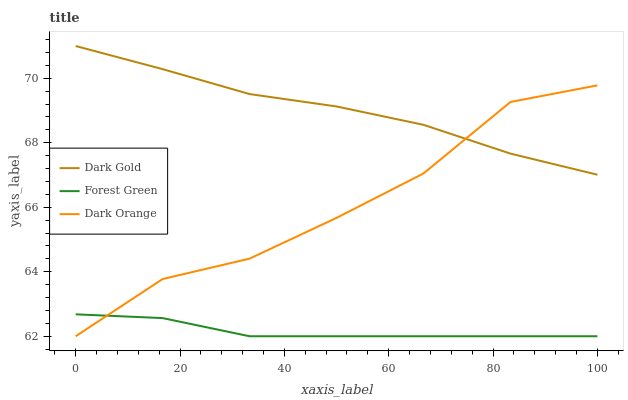Does Forest Green have the minimum area under the curve?
Answer yes or no. Yes. Does Dark Gold have the maximum area under the curve?
Answer yes or no. Yes. Does Dark Gold have the minimum area under the curve?
Answer yes or no. No. Does Forest Green have the maximum area under the curve?
Answer yes or no. No. Is Forest Green the smoothest?
Answer yes or no. Yes. Is Dark Orange the roughest?
Answer yes or no. Yes. Is Dark Gold the smoothest?
Answer yes or no. No. Is Dark Gold the roughest?
Answer yes or no. No. Does Dark Orange have the lowest value?
Answer yes or no. Yes. Does Dark Gold have the lowest value?
Answer yes or no. No. Does Dark Gold have the highest value?
Answer yes or no. Yes. Does Forest Green have the highest value?
Answer yes or no. No. Is Forest Green less than Dark Gold?
Answer yes or no. Yes. Is Dark Gold greater than Forest Green?
Answer yes or no. Yes. Does Dark Orange intersect Forest Green?
Answer yes or no. Yes. Is Dark Orange less than Forest Green?
Answer yes or no. No. Is Dark Orange greater than Forest Green?
Answer yes or no. No. Does Forest Green intersect Dark Gold?
Answer yes or no. No. 